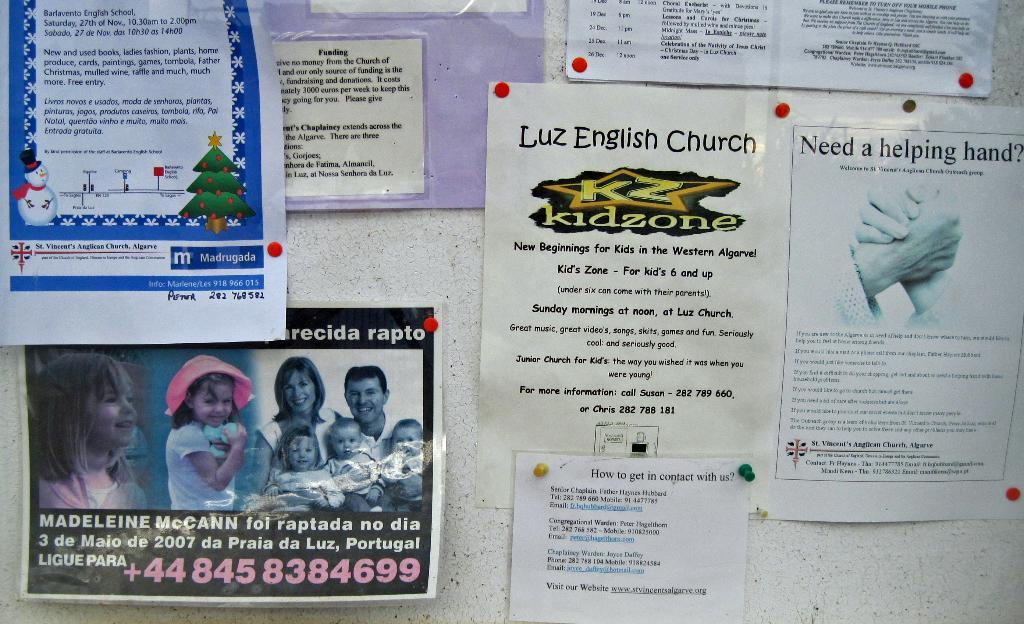<image>
Write a terse but informative summary of the picture. A bulletin board with different church flyers including a missing person's flyer for Madeleine McCann. 